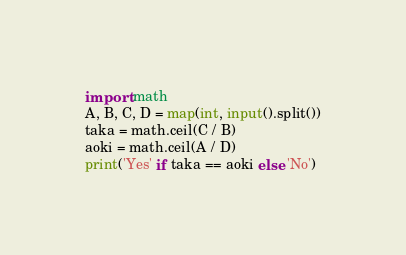<code> <loc_0><loc_0><loc_500><loc_500><_Python_>import math
A, B, C, D = map(int, input().split())
taka = math.ceil(C / B)
aoki = math.ceil(A / D)
print('Yes' if taka == aoki else 'No')</code> 